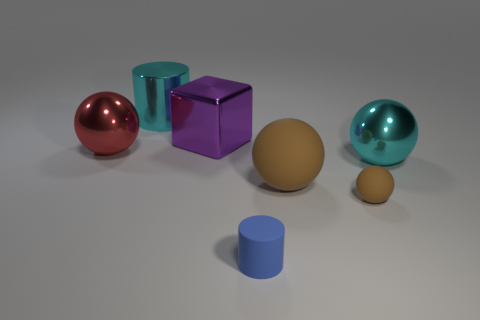Is the shape of the cyan object that is to the left of the big cyan ball the same as  the blue object?
Give a very brief answer. Yes. Are there fewer big cyan metallic balls than big blue shiny cylinders?
Keep it short and to the point. No. Is there anything else of the same color as the rubber cylinder?
Make the answer very short. No. There is a large cyan thing in front of the large red thing; what shape is it?
Make the answer very short. Sphere. Does the metal cylinder have the same color as the large object that is on the right side of the small ball?
Provide a succinct answer. Yes. Is the number of small things right of the small brown thing the same as the number of big rubber balls that are to the left of the cyan metal cylinder?
Make the answer very short. Yes. What number of other things are there of the same size as the purple shiny cube?
Your answer should be compact. 4. The metal cylinder has what size?
Provide a short and direct response. Large. Does the small sphere have the same material as the cylinder that is in front of the purple metallic cube?
Make the answer very short. Yes. Are there any big cyan objects that have the same shape as the tiny blue rubber object?
Offer a terse response. Yes. 